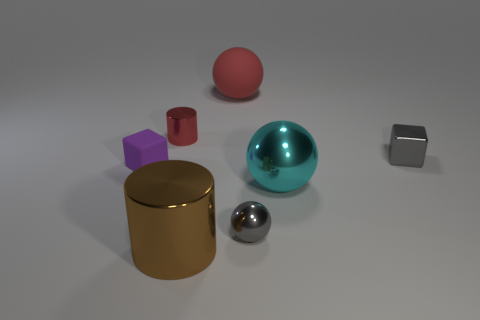Is there anything else that has the same color as the tiny metal sphere?
Provide a short and direct response. Yes. There is a shiny cylinder in front of the gray metal thing in front of the big cyan sphere that is right of the tiny purple cube; how big is it?
Your response must be concise. Large. The metal thing that is on the right side of the small shiny ball and behind the large cyan metal sphere is what color?
Offer a terse response. Gray. There is a shiny cylinder in front of the red metallic cylinder; what is its size?
Your answer should be very brief. Large. What number of purple blocks are the same material as the large red thing?
Provide a short and direct response. 1. What shape is the metallic object that is the same color as the small ball?
Ensure brevity in your answer.  Cube. Does the tiny gray thing that is right of the gray sphere have the same shape as the cyan metal object?
Your answer should be very brief. No. The small sphere that is the same material as the small red cylinder is what color?
Keep it short and to the point. Gray. Are there any big red balls behind the red thing in front of the matte object that is on the right side of the tiny cylinder?
Your response must be concise. Yes. There is a tiny rubber object; what shape is it?
Your response must be concise. Cube. 